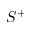<formula> <loc_0><loc_0><loc_500><loc_500>S ^ { + }</formula> 